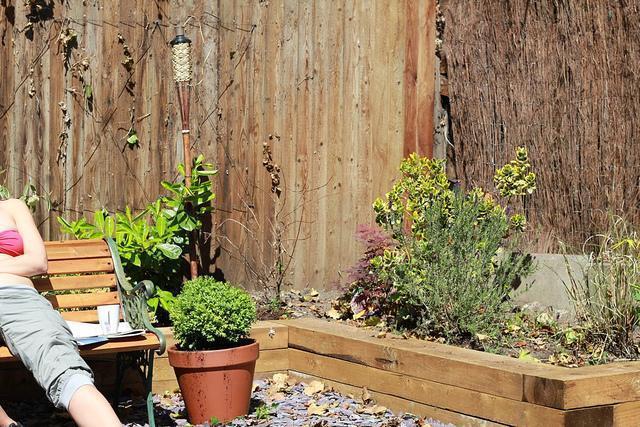How many horses are there?
Give a very brief answer. 0. 